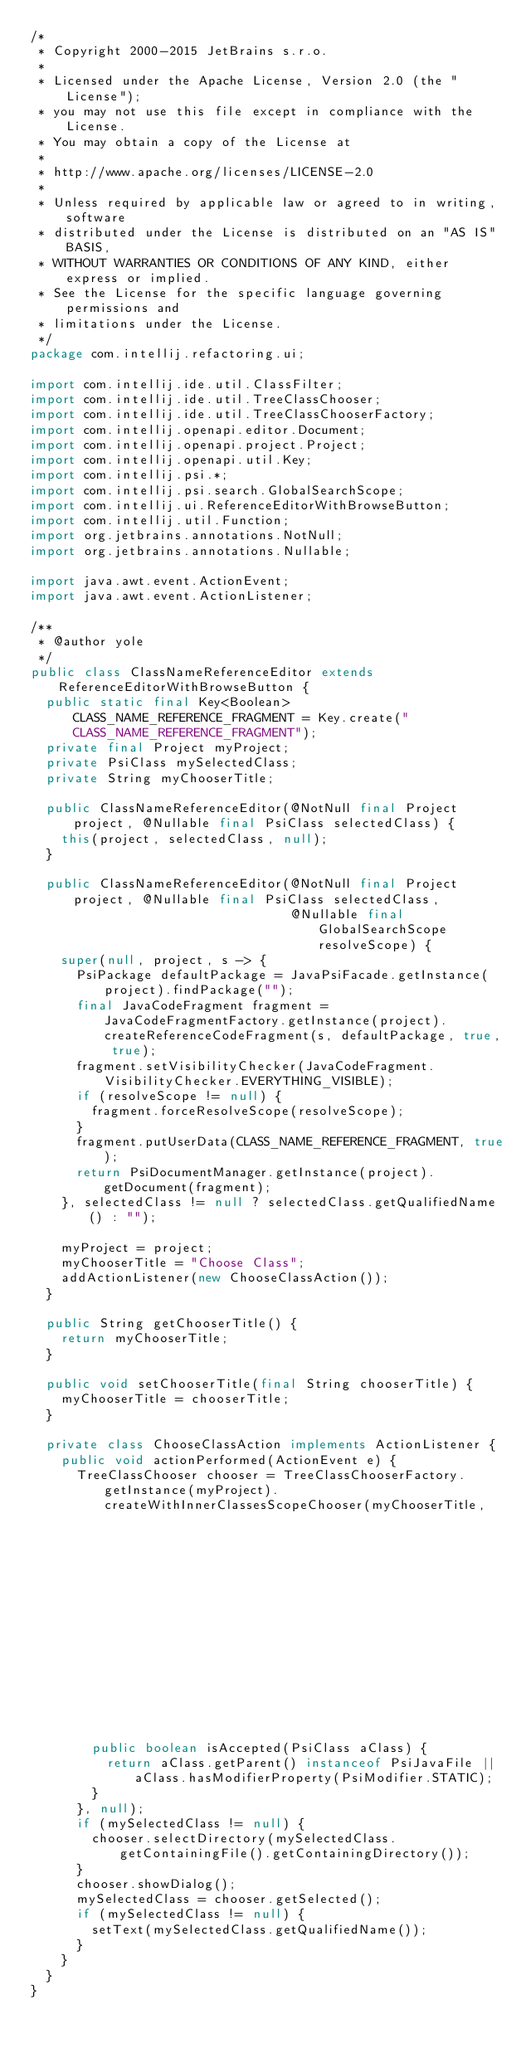<code> <loc_0><loc_0><loc_500><loc_500><_Java_>/*
 * Copyright 2000-2015 JetBrains s.r.o.
 *
 * Licensed under the Apache License, Version 2.0 (the "License");
 * you may not use this file except in compliance with the License.
 * You may obtain a copy of the License at
 *
 * http://www.apache.org/licenses/LICENSE-2.0
 *
 * Unless required by applicable law or agreed to in writing, software
 * distributed under the License is distributed on an "AS IS" BASIS,
 * WITHOUT WARRANTIES OR CONDITIONS OF ANY KIND, either express or implied.
 * See the License for the specific language governing permissions and
 * limitations under the License.
 */
package com.intellij.refactoring.ui;

import com.intellij.ide.util.ClassFilter;
import com.intellij.ide.util.TreeClassChooser;
import com.intellij.ide.util.TreeClassChooserFactory;
import com.intellij.openapi.editor.Document;
import com.intellij.openapi.project.Project;
import com.intellij.openapi.util.Key;
import com.intellij.psi.*;
import com.intellij.psi.search.GlobalSearchScope;
import com.intellij.ui.ReferenceEditorWithBrowseButton;
import com.intellij.util.Function;
import org.jetbrains.annotations.NotNull;
import org.jetbrains.annotations.Nullable;

import java.awt.event.ActionEvent;
import java.awt.event.ActionListener;

/**
 * @author yole
 */
public class ClassNameReferenceEditor extends ReferenceEditorWithBrowseButton {
  public static final Key<Boolean> CLASS_NAME_REFERENCE_FRAGMENT = Key.create("CLASS_NAME_REFERENCE_FRAGMENT");
  private final Project myProject;
  private PsiClass mySelectedClass;
  private String myChooserTitle;

  public ClassNameReferenceEditor(@NotNull final Project project, @Nullable final PsiClass selectedClass) {
    this(project, selectedClass, null);
  }

  public ClassNameReferenceEditor(@NotNull final Project project, @Nullable final PsiClass selectedClass,
                                  @Nullable final GlobalSearchScope resolveScope) {
    super(null, project, s -> {
      PsiPackage defaultPackage = JavaPsiFacade.getInstance(project).findPackage("");
      final JavaCodeFragment fragment = JavaCodeFragmentFactory.getInstance(project).createReferenceCodeFragment(s, defaultPackage, true, true);
      fragment.setVisibilityChecker(JavaCodeFragment.VisibilityChecker.EVERYTHING_VISIBLE);
      if (resolveScope != null) {
        fragment.forceResolveScope(resolveScope);
      }
      fragment.putUserData(CLASS_NAME_REFERENCE_FRAGMENT, true);
      return PsiDocumentManager.getInstance(project).getDocument(fragment);
    }, selectedClass != null ? selectedClass.getQualifiedName() : "");

    myProject = project;
    myChooserTitle = "Choose Class";
    addActionListener(new ChooseClassAction());
  }

  public String getChooserTitle() {
    return myChooserTitle;
  }

  public void setChooserTitle(final String chooserTitle) {
    myChooserTitle = chooserTitle;
  }

  private class ChooseClassAction implements ActionListener {
    public void actionPerformed(ActionEvent e) {
      TreeClassChooser chooser = TreeClassChooserFactory.getInstance(myProject).createWithInnerClassesScopeChooser(myChooserTitle,
                                                                                                                   GlobalSearchScope.projectScope(myProject),
                                                                                                                   new ClassFilter() {
        public boolean isAccepted(PsiClass aClass) {
          return aClass.getParent() instanceof PsiJavaFile || aClass.hasModifierProperty(PsiModifier.STATIC);
        }
      }, null);
      if (mySelectedClass != null) {
        chooser.selectDirectory(mySelectedClass.getContainingFile().getContainingDirectory());
      }
      chooser.showDialog();
      mySelectedClass = chooser.getSelected();
      if (mySelectedClass != null) {
        setText(mySelectedClass.getQualifiedName());
      }
    }
  }
}</code> 